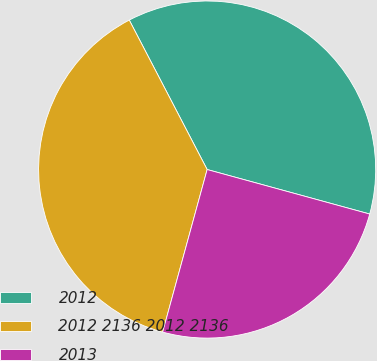Convert chart to OTSL. <chart><loc_0><loc_0><loc_500><loc_500><pie_chart><fcel>2012<fcel>2012 2136 2012 2136<fcel>2013<nl><fcel>36.9%<fcel>38.1%<fcel>25.0%<nl></chart> 